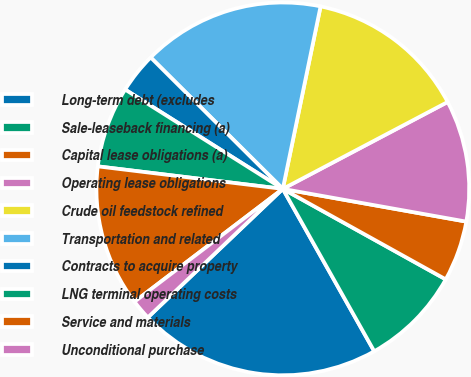Convert chart. <chart><loc_0><loc_0><loc_500><loc_500><pie_chart><fcel>Long-term debt (excludes<fcel>Sale-leaseback financing (a)<fcel>Capital lease obligations (a)<fcel>Operating lease obligations<fcel>Crude oil feedstock refined<fcel>Transportation and related<fcel>Contracts to acquire property<fcel>LNG terminal operating costs<fcel>Service and materials<fcel>Unconditional purchase<nl><fcel>21.05%<fcel>8.77%<fcel>5.26%<fcel>10.53%<fcel>14.03%<fcel>15.79%<fcel>3.51%<fcel>7.02%<fcel>12.28%<fcel>1.76%<nl></chart> 